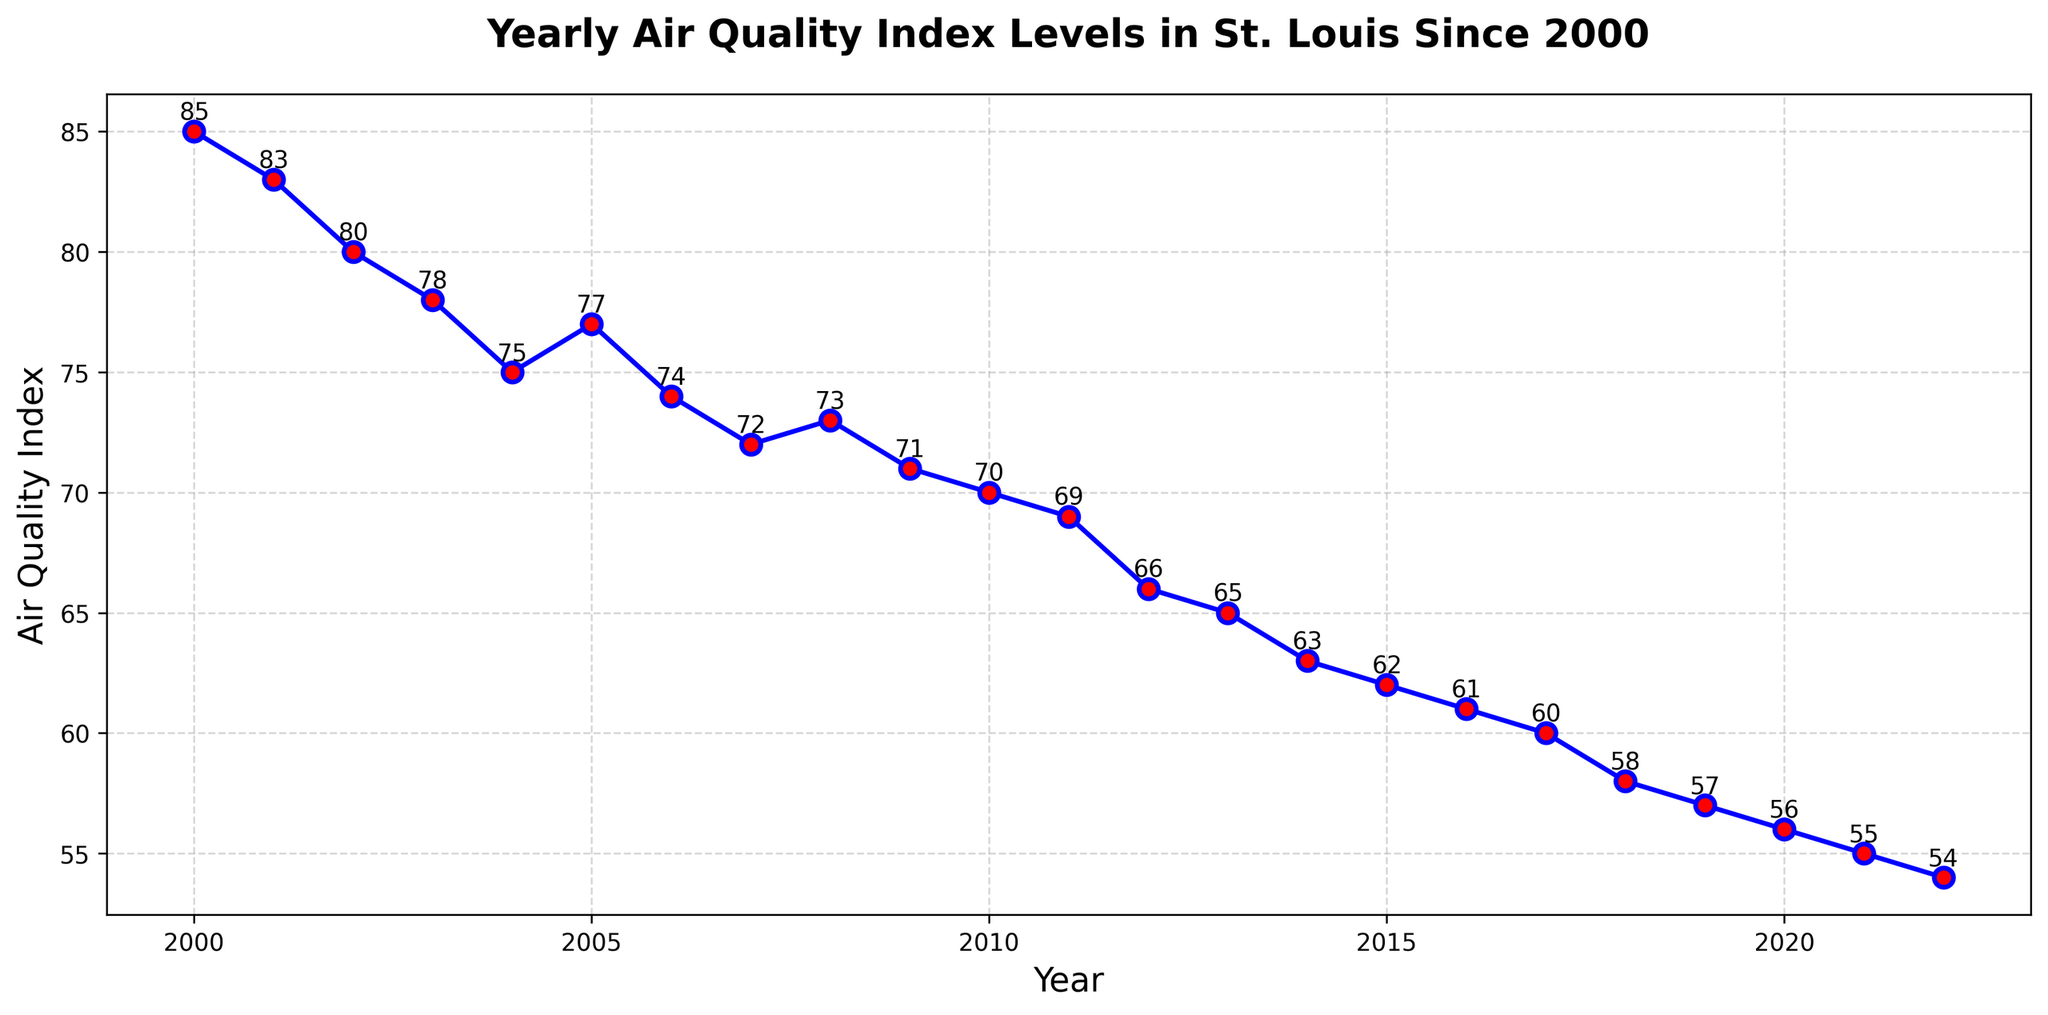What is the Air Quality Index level trend from 2000 to 2022? The Air Quality Index levels consistently decrease from 2000 to 2022. The line on the plot slopes downward, indicating improvement in air quality over the years.
Answer: Decreasing trend Which year had the highest Air Quality Index level, and what was the value? The highest Air Quality Index level was in the year 2000 at 85. This can be observed at the starting point of the plotted line at 2000.
Answer: 2000, 85 In which year did the Air Quality Index level first go below 70? Observing the labels on the plot, the Air Quality Index level first went below 70 in the year 2011, where the level is 69.
Answer: 2011 What is the difference in the Air Quality Index level between the year 2000 and 2022? The Air Quality Index level in 2000 was 85 and in 2022, it was 54. The difference is calculated as 85 - 54 = 31.
Answer: 31 During which time period did the fastest decline in Air Quality Index levels occur? The fastest decline occurred between 2011 (69) and 2012 (66). The line segment between these years shows the steepest drop.
Answer: 2011 to 2012 What is the average Air Quality Index level for the years 2010 to 2020? The Air Quality Index levels for 2010 to 2020 are: 70, 69, 66, 65, 63, 62, 61, 60, 58, 57, 56. The average is (70 + 69 + 66 + 65 + 63 + 62 + 61 + 60 + 58 + 57 + 56) / 11 = 63.
Answer: 63 How many years had an Air Quality Index level above 70? By counting the years where the AQI level is above 70 on the plot (2000-2004 and 2005-2007), we have a total of 7 years.
Answer: 7 years Which year had an Air Quality Index level closest to 60, and what was the exact level? The year is 2017, with the Air Quality Index level at 60, visible from the label just below this level on the plot.
Answer: 2017, 60 From 2000 to 2022, which two consecutive years had the smallest change in the Air Quality Index level? The smallest change occurred between 2004 (75) and 2005 (77), as the line between these two points is almost flat, marking a difference of only 2 units.
Answer: 2004 to 2005 What was the Air Quality Index level in the median year of the dataset, and how is the median year determined? The median year of the dataset, 2000 to 2022, can be determined by taking the middle value in the ordered list of years. Since there are 23 years, the median year is the 12th year, which is 2011. The Air Quality Index level in 2011 is 69.
Answer: 2011, 69 